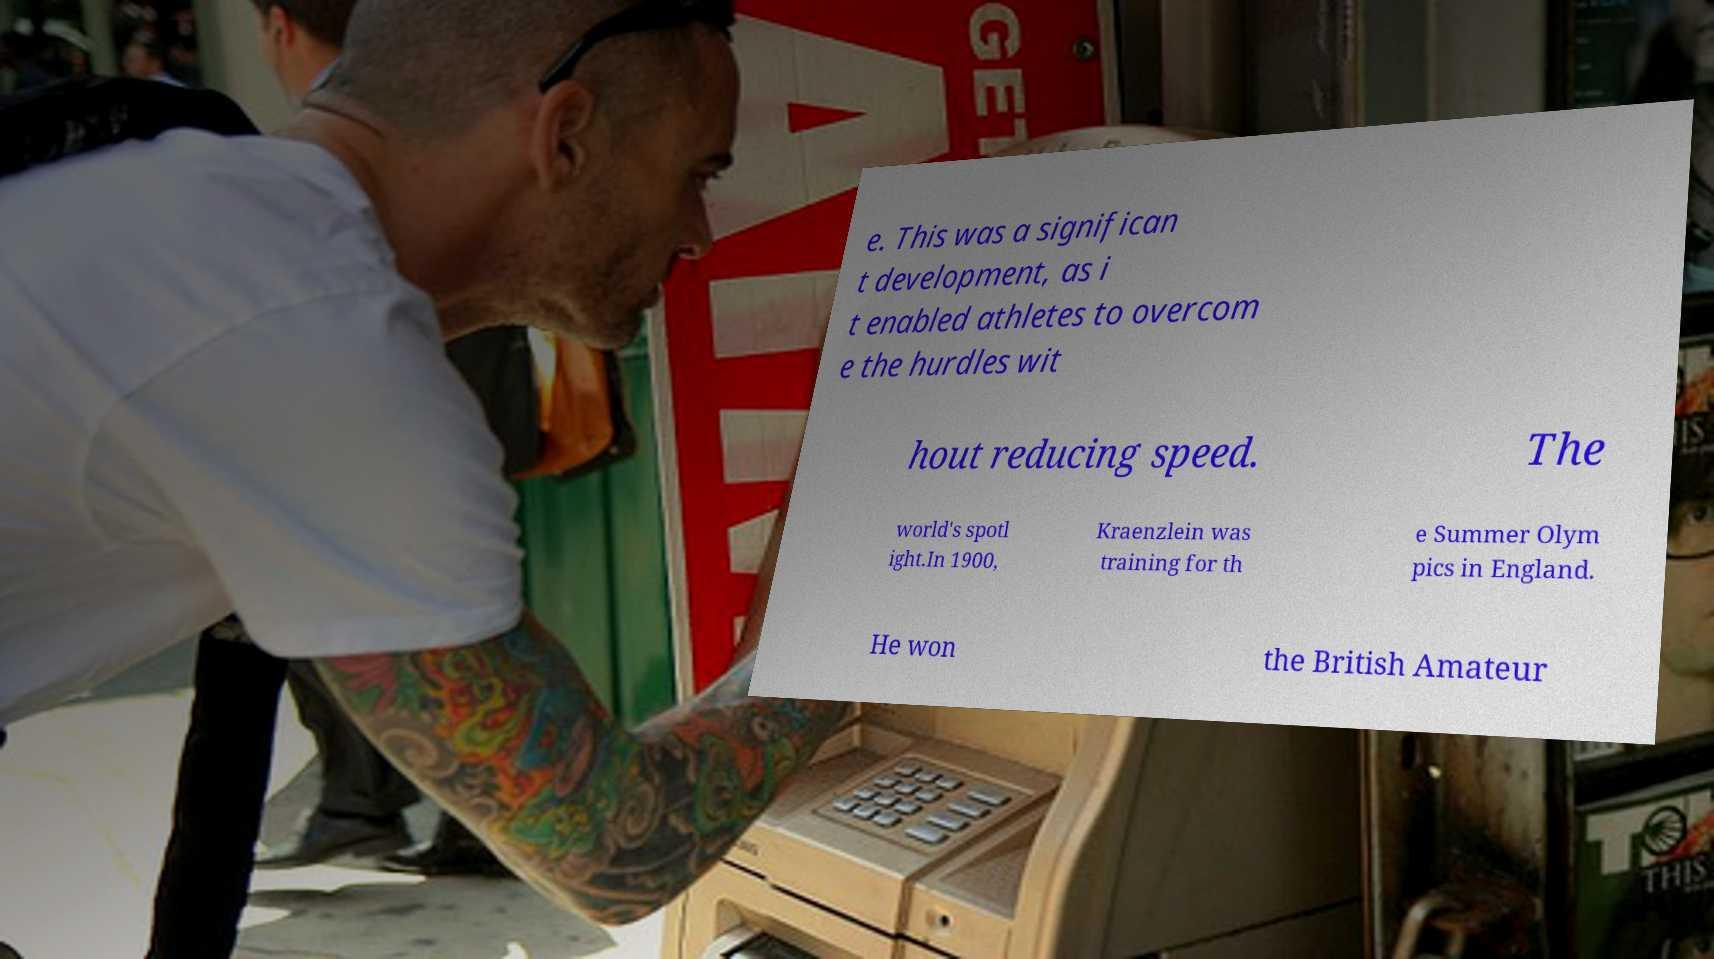Could you assist in decoding the text presented in this image and type it out clearly? e. This was a significan t development, as i t enabled athletes to overcom e the hurdles wit hout reducing speed. The world's spotl ight.In 1900, Kraenzlein was training for th e Summer Olym pics in England. He won the British Amateur 